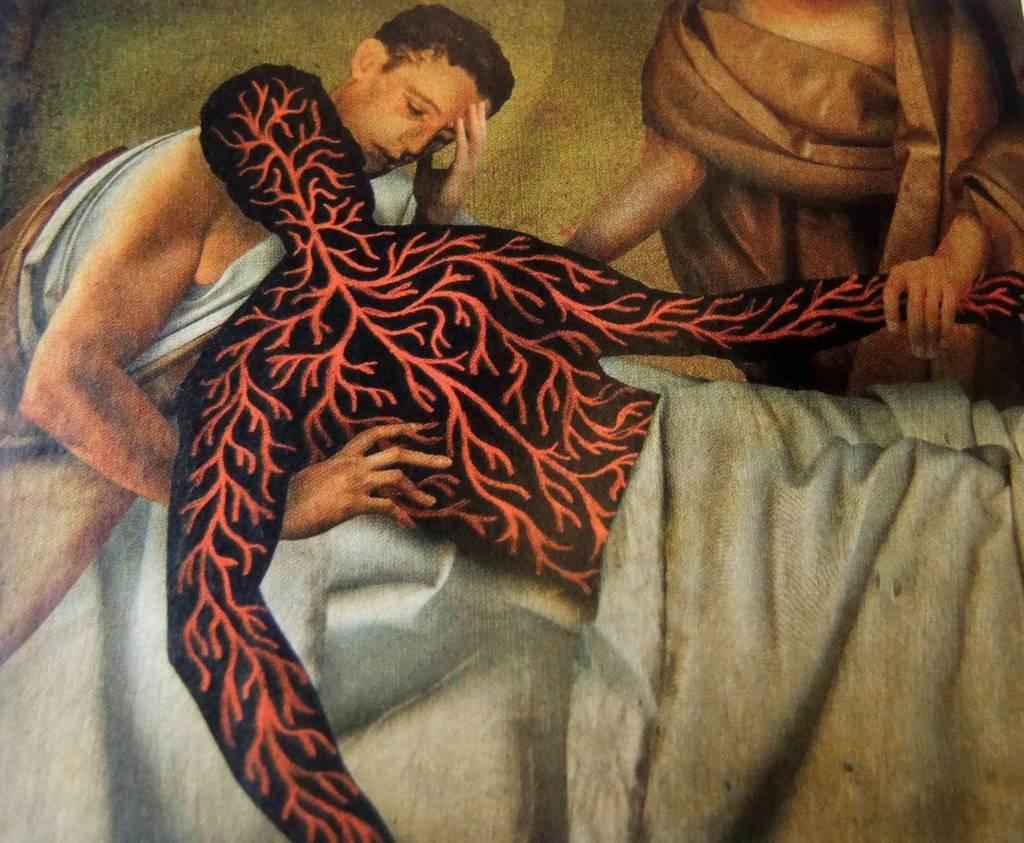What is the main subject of the image? The image contains an art piece. Can you describe the art piece? The art piece features two persons, and there is a blanket covering the body of one or both persons. What is the current status of the foot in the art piece? There is no mention of a foot in the art piece, so it cannot be determined if it has a current status. 